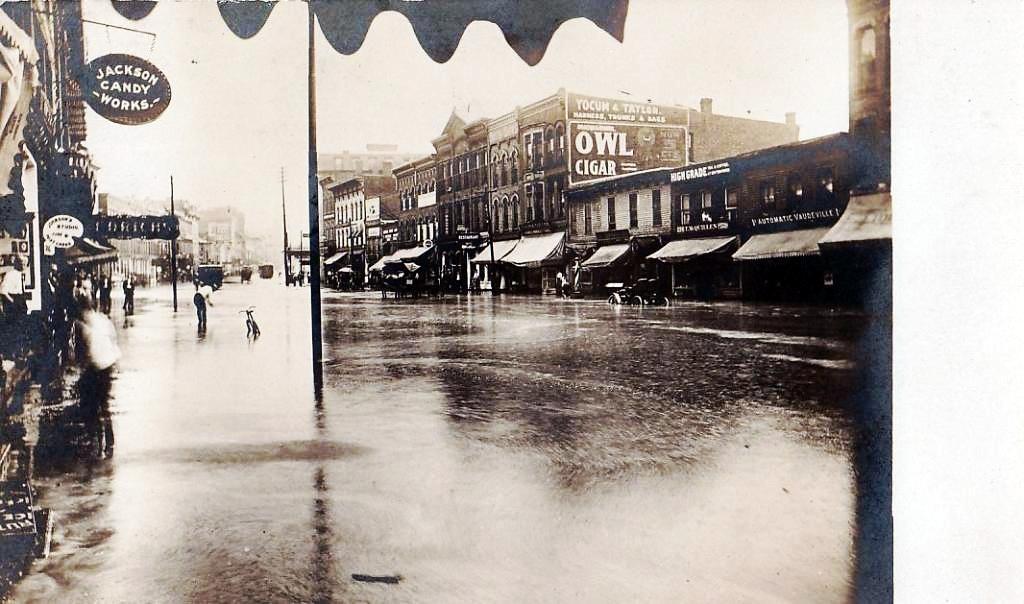Describe this image in one or two sentences. This is a black and white image. In this image, on the right side, we can see some buildings, stalls and few vehicles which are moving on the road. On the left side, we can also see some buildings, hoardings, a group of people. In the middle of the image, we can see a pole and a person standing, vehicles. In the background, we can also see some buildings. At the top, we can see a sky, at the bottom, we can see a road with some water. 